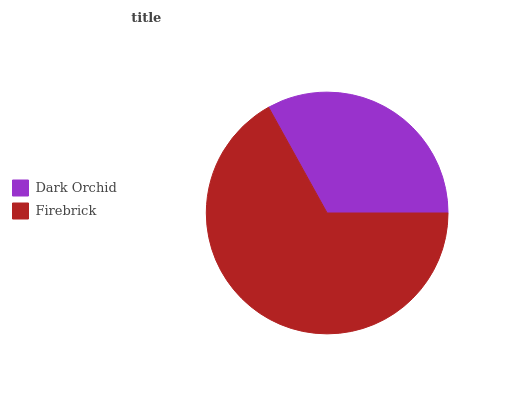Is Dark Orchid the minimum?
Answer yes or no. Yes. Is Firebrick the maximum?
Answer yes or no. Yes. Is Firebrick the minimum?
Answer yes or no. No. Is Firebrick greater than Dark Orchid?
Answer yes or no. Yes. Is Dark Orchid less than Firebrick?
Answer yes or no. Yes. Is Dark Orchid greater than Firebrick?
Answer yes or no. No. Is Firebrick less than Dark Orchid?
Answer yes or no. No. Is Firebrick the high median?
Answer yes or no. Yes. Is Dark Orchid the low median?
Answer yes or no. Yes. Is Dark Orchid the high median?
Answer yes or no. No. Is Firebrick the low median?
Answer yes or no. No. 